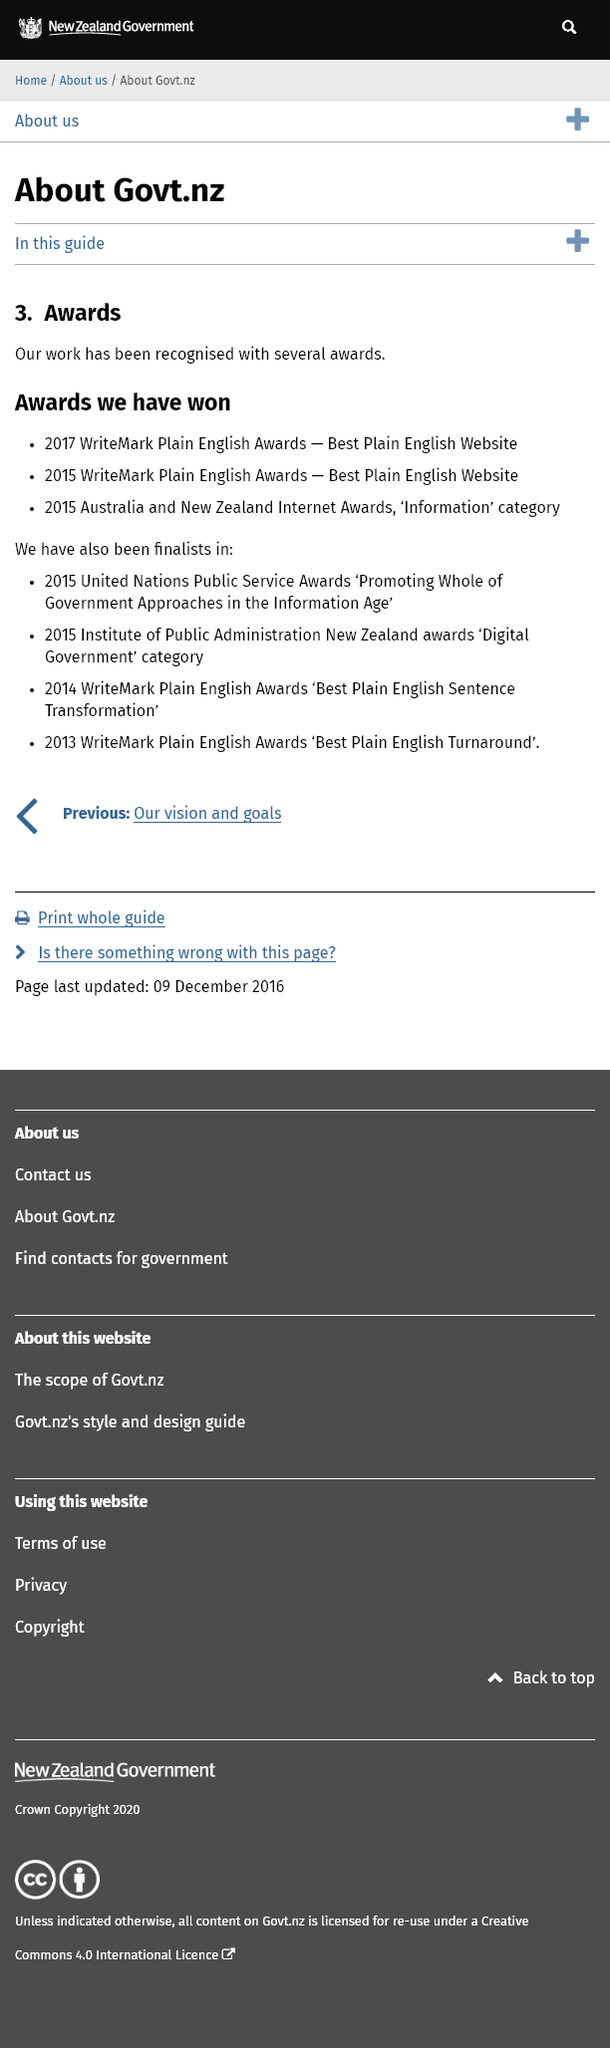Outline some significant characteristics in this image. In 2015, Govt.nz was both a finalist for a United Nations Public Service Award and a winner of a WriteMark Plain English Award. Specifically, Govt.nz was recognized for its plain English website and received the WriteMark Plain English Award for "Best Plain English Website. In 2015, Govt.nz was a finalist for the Institute of Public Administration New Zealand's 'Digital Government' award. The government website, Govt.nz, was awarded the WriteMark Plain English Awards in 2015 and 2017. 